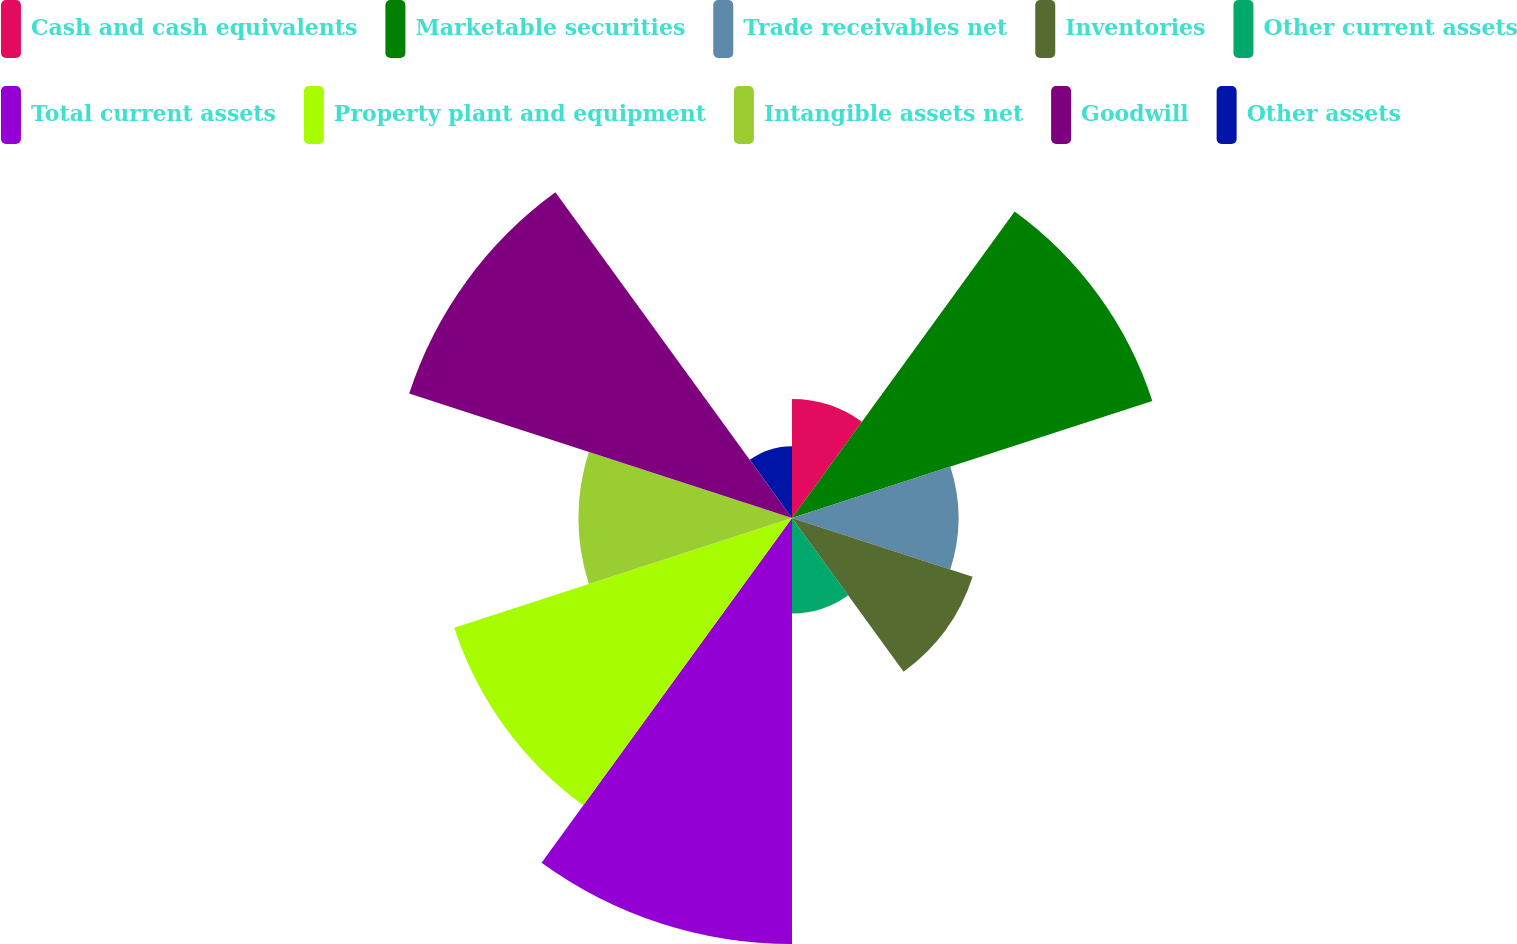Convert chart to OTSL. <chart><loc_0><loc_0><loc_500><loc_500><pie_chart><fcel>Cash and cash equivalents<fcel>Marketable securities<fcel>Trade receivables net<fcel>Inventories<fcel>Other current assets<fcel>Total current assets<fcel>Property plant and equipment<fcel>Intangible assets net<fcel>Goodwill<fcel>Other assets<nl><fcel>4.92%<fcel>15.66%<fcel>6.88%<fcel>7.85%<fcel>3.95%<fcel>17.61%<fcel>14.68%<fcel>8.83%<fcel>16.64%<fcel>2.97%<nl></chart> 